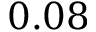Convert formula to latex. <formula><loc_0><loc_0><loc_500><loc_500>0 . 0 8</formula> 